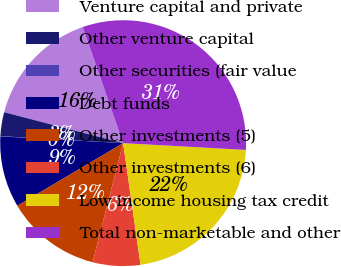Convert chart. <chart><loc_0><loc_0><loc_500><loc_500><pie_chart><fcel>Venture capital and private<fcel>Other venture capital<fcel>Other securities (fair value<fcel>Debt funds<fcel>Other investments (5)<fcel>Other investments (6)<fcel>Low income housing tax credit<fcel>Total non-marketable and other<nl><fcel>15.62%<fcel>3.14%<fcel>0.03%<fcel>9.38%<fcel>12.5%<fcel>6.26%<fcel>21.86%<fcel>31.21%<nl></chart> 